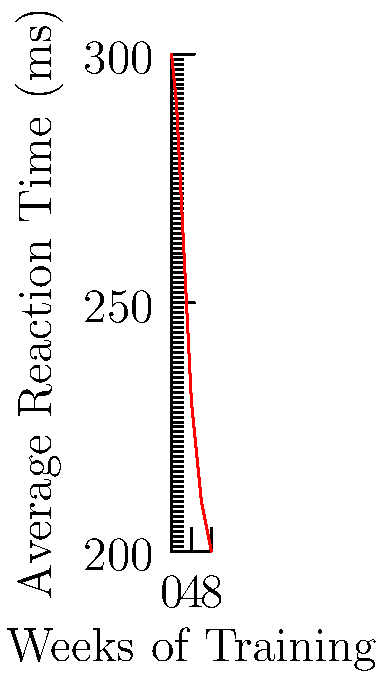Based on the graph showing the improvement in average reaction time over 8 weeks of training, what is the approximate percentage decrease in reaction time from week 0 to week 8? To calculate the percentage decrease in reaction time:

1. Identify the initial reaction time (week 0): 300 ms
2. Identify the final reaction time (week 8): 200 ms
3. Calculate the absolute decrease: 300 ms - 200 ms = 100 ms
4. Calculate the percentage decrease:
   $\text{Percentage decrease} = \frac{\text{Decrease}}{\text{Initial value}} \times 100\%$
   $= \frac{100 \text{ ms}}{300 \text{ ms}} \times 100\% = 0.3333... \times 100\% \approx 33.33\%$

Therefore, the approximate percentage decrease in reaction time from week 0 to week 8 is 33.33%.
Answer: 33.33% 